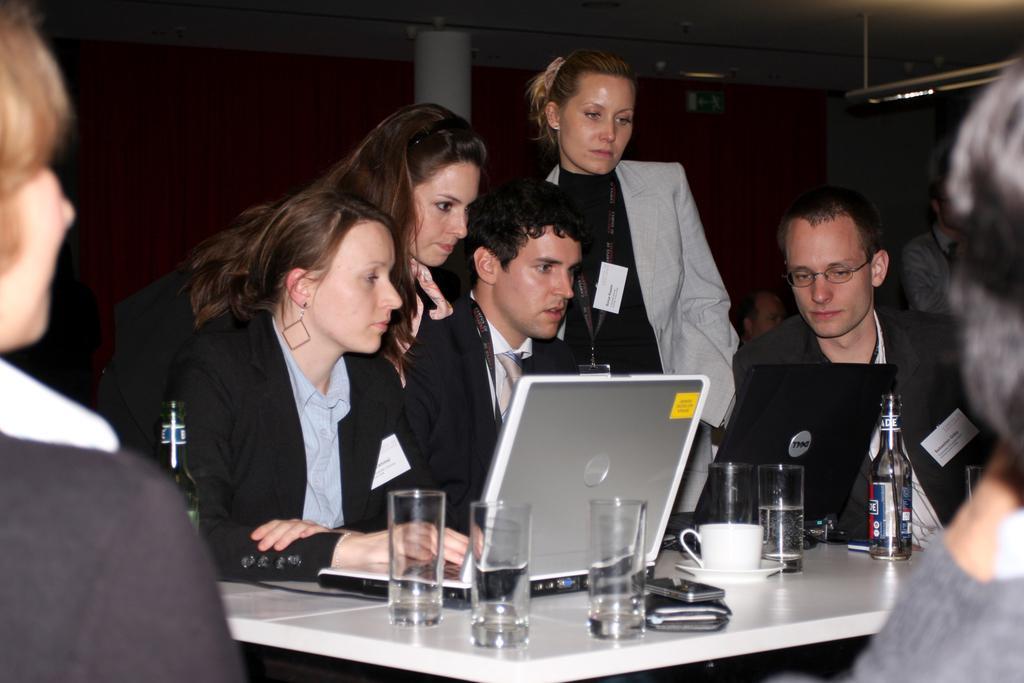Could you give a brief overview of what you see in this image? Here, in this picture we see one two three four five six seven eight nine, nine people. Out of them, five are women and four are men. Two men and a woman is sitting on chair and operating laptops. These laptops are placed on the table. On table we find glasses, cup, saucer, valet, bottle and the two women are standing and looking at the laptop. Behind them, we find pillar and a wall. 